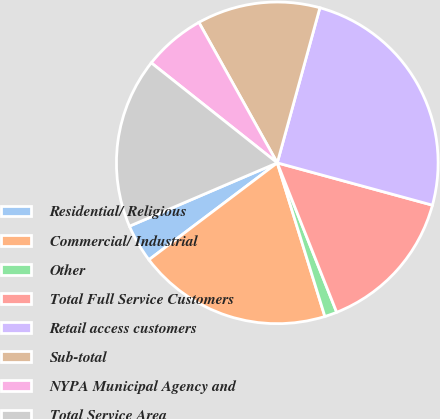Convert chart to OTSL. <chart><loc_0><loc_0><loc_500><loc_500><pie_chart><fcel>Residential/ Religious<fcel>Commercial/ Industrial<fcel>Other<fcel>Total Full Service Customers<fcel>Retail access customers<fcel>Sub-total<fcel>NYPA Municipal Agency and<fcel>Total Service Area<nl><fcel>3.85%<fcel>19.49%<fcel>1.24%<fcel>14.74%<fcel>24.97%<fcel>12.37%<fcel>6.22%<fcel>17.12%<nl></chart> 